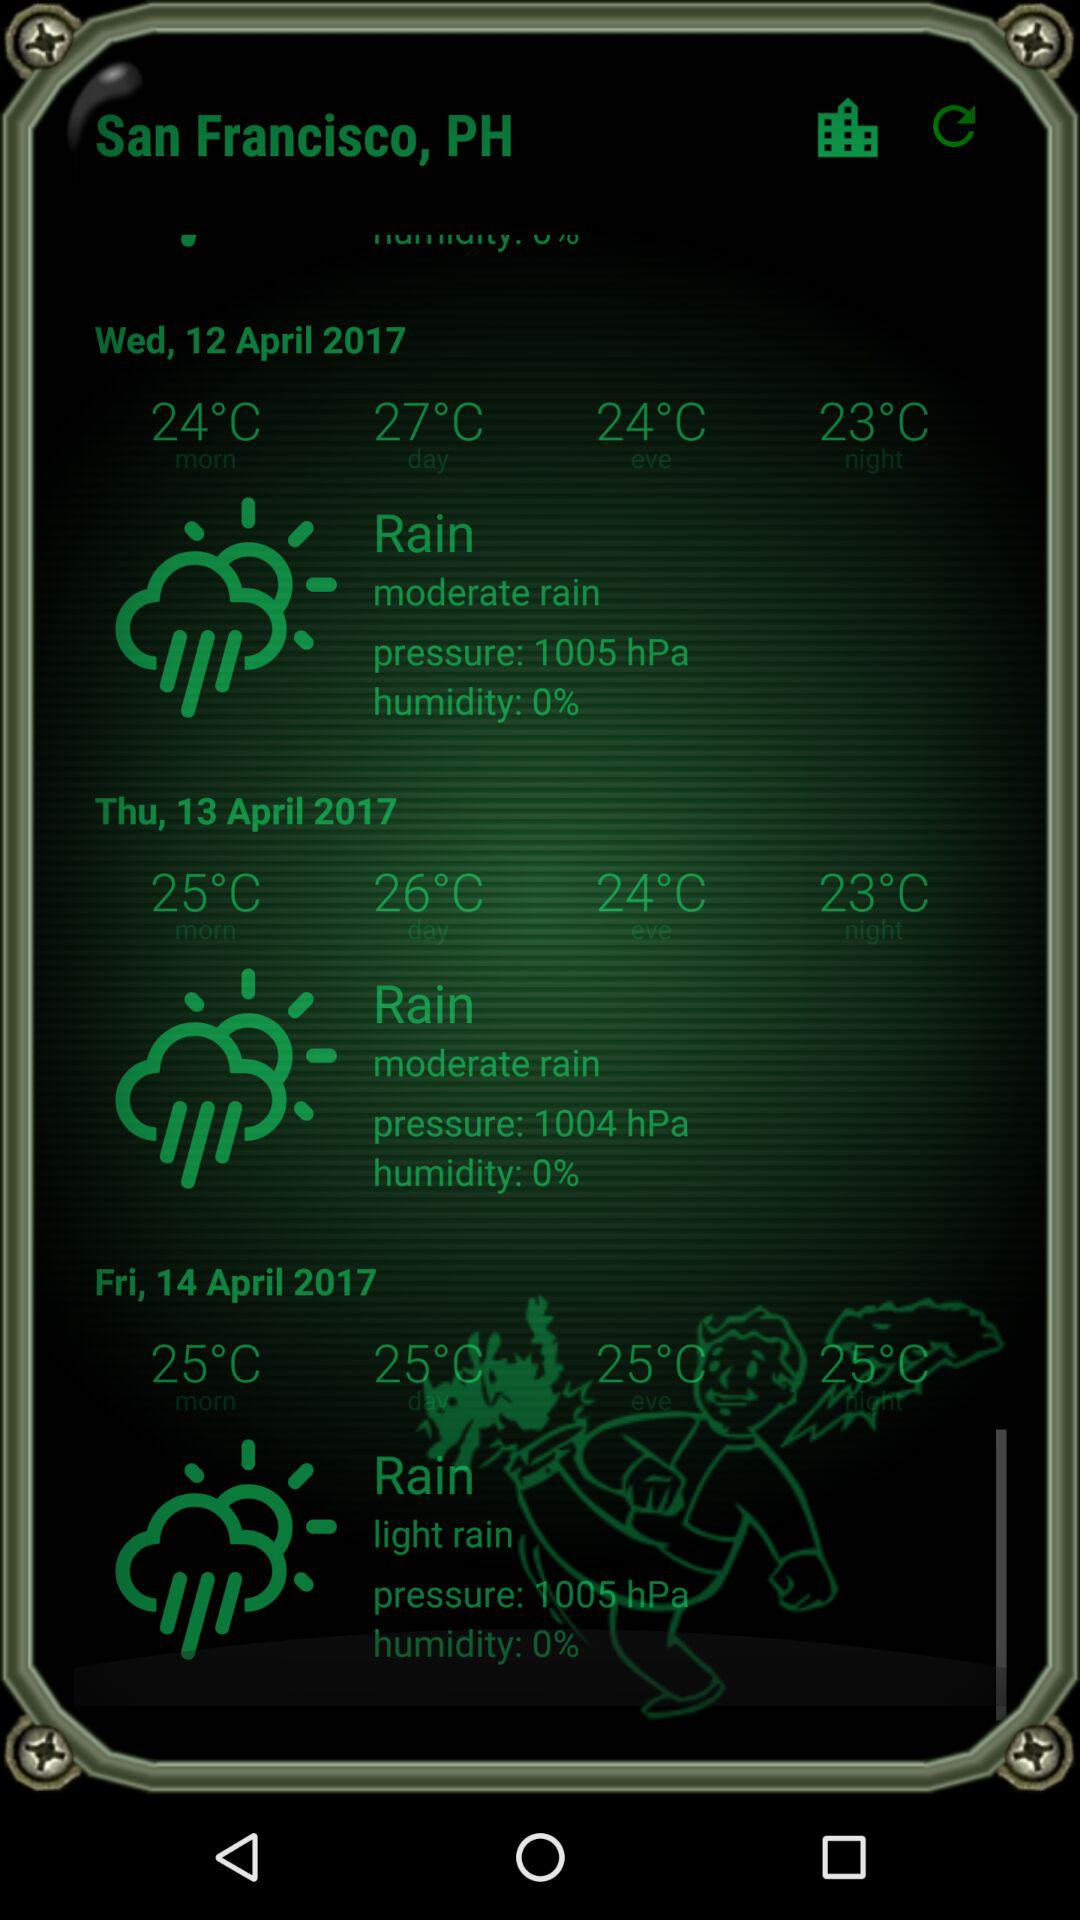How is the weather on Thursday? The weather on Thursday is moderately rainy. 